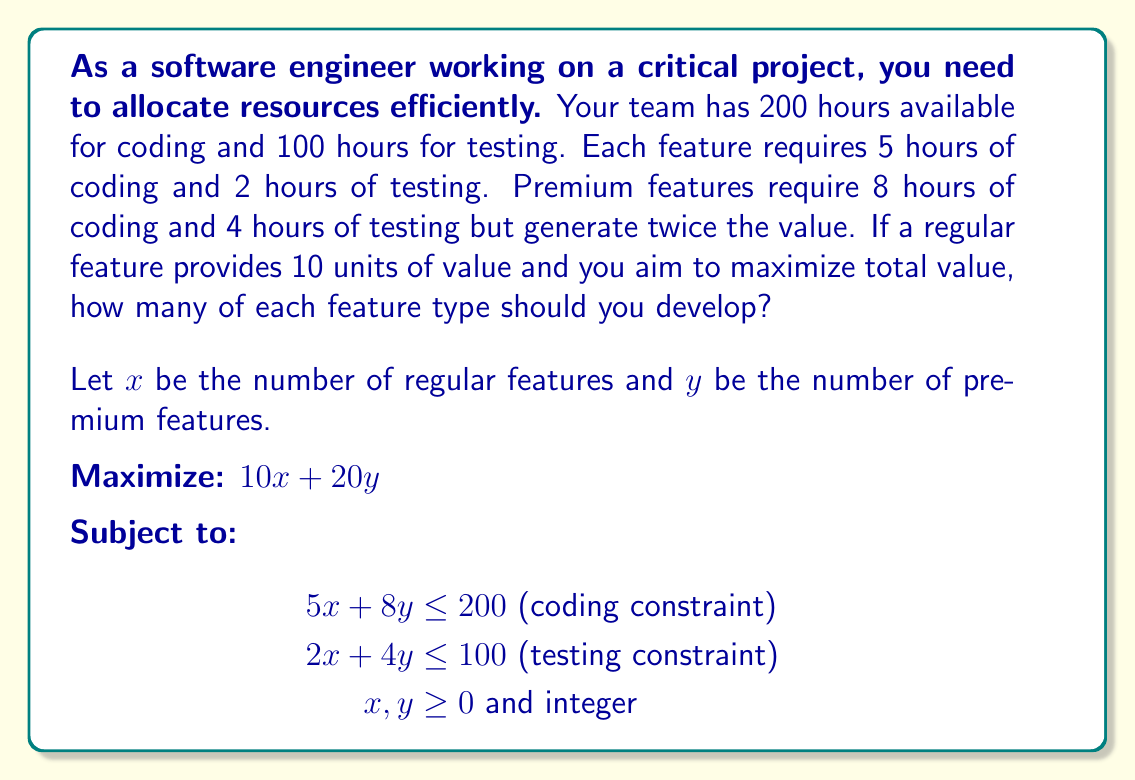What is the answer to this math problem? To solve this linear programming problem, we'll use the graphical method:

1. Plot the constraints:
   - Coding: $5x + 8y = 200$ intercepts at (40, 0) and (0, 25)
   - Testing: $2x + 4y = 100$ intercepts at (50, 0) and (0, 25)

2. Identify the feasible region:
   The feasible region is bounded by these lines and the axes.

3. Find the corner points of the feasible region:
   (0, 0), (0, 25), (40, 0), and the intersection of the two constraints.

4. Solve for the intersection point:
   $$\begin{align}
   5x + 8y &= 200 \\
   2x + 4y &= 100
   \end{align}$$
   Multiplying the second equation by 2.5 and subtracting:
   $$\begin{align}
   5x + 8y &= 200 \\
   5x + 10y &= 250 \\
   -2y &= -50 \\
   y &= 25
   \end{align}$$
   Substituting back:
   $$\begin{align}
   5x + 8(25) &= 200 \\
   5x &= 0 \\
   x &= 0
   \end{align}$$
   The intersection point is (0, 25).

5. Evaluate the objective function at each corner point:
   - (0, 0): $10(0) + 20(0) = 0$
   - (0, 25): $10(0) + 20(25) = 500$
   - (40, 0): $10(40) + 20(0) = 400$

6. The maximum value occurs at (0, 25), meaning 0 regular features and 25 premium features.

7. Check for integer solutions near (0, 25):
   - (0, 25): Valid and optimal
   - (1, 24): Not feasible (exceeds constraints)

Therefore, the optimal integer solution is 0 regular features and 25 premium features.
Answer: 0 regular features, 25 premium features 